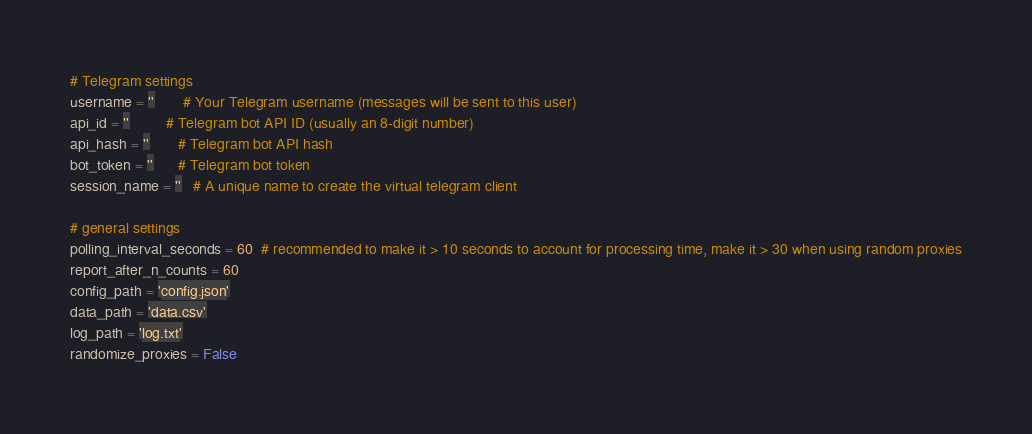<code> <loc_0><loc_0><loc_500><loc_500><_Python_># Telegram settings
username = ''       # Your Telegram username (messages will be sent to this user)
api_id = ''         # Telegram bot API ID (usually an 8-digit number)
api_hash = ''       # Telegram bot API hash
bot_token = ''      # Telegram bot token
session_name = ''   # A unique name to create the virtual telegram client

# general settings
polling_interval_seconds = 60  # recommended to make it > 10 seconds to account for processing time, make it > 30 when using random proxies
report_after_n_counts = 60
config_path = 'config.json'
data_path = 'data.csv'
log_path = 'log.txt'
randomize_proxies = False
</code> 